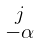Convert formula to latex. <formula><loc_0><loc_0><loc_500><loc_500>\begin{smallmatrix} j \\ - \alpha \end{smallmatrix}</formula> 